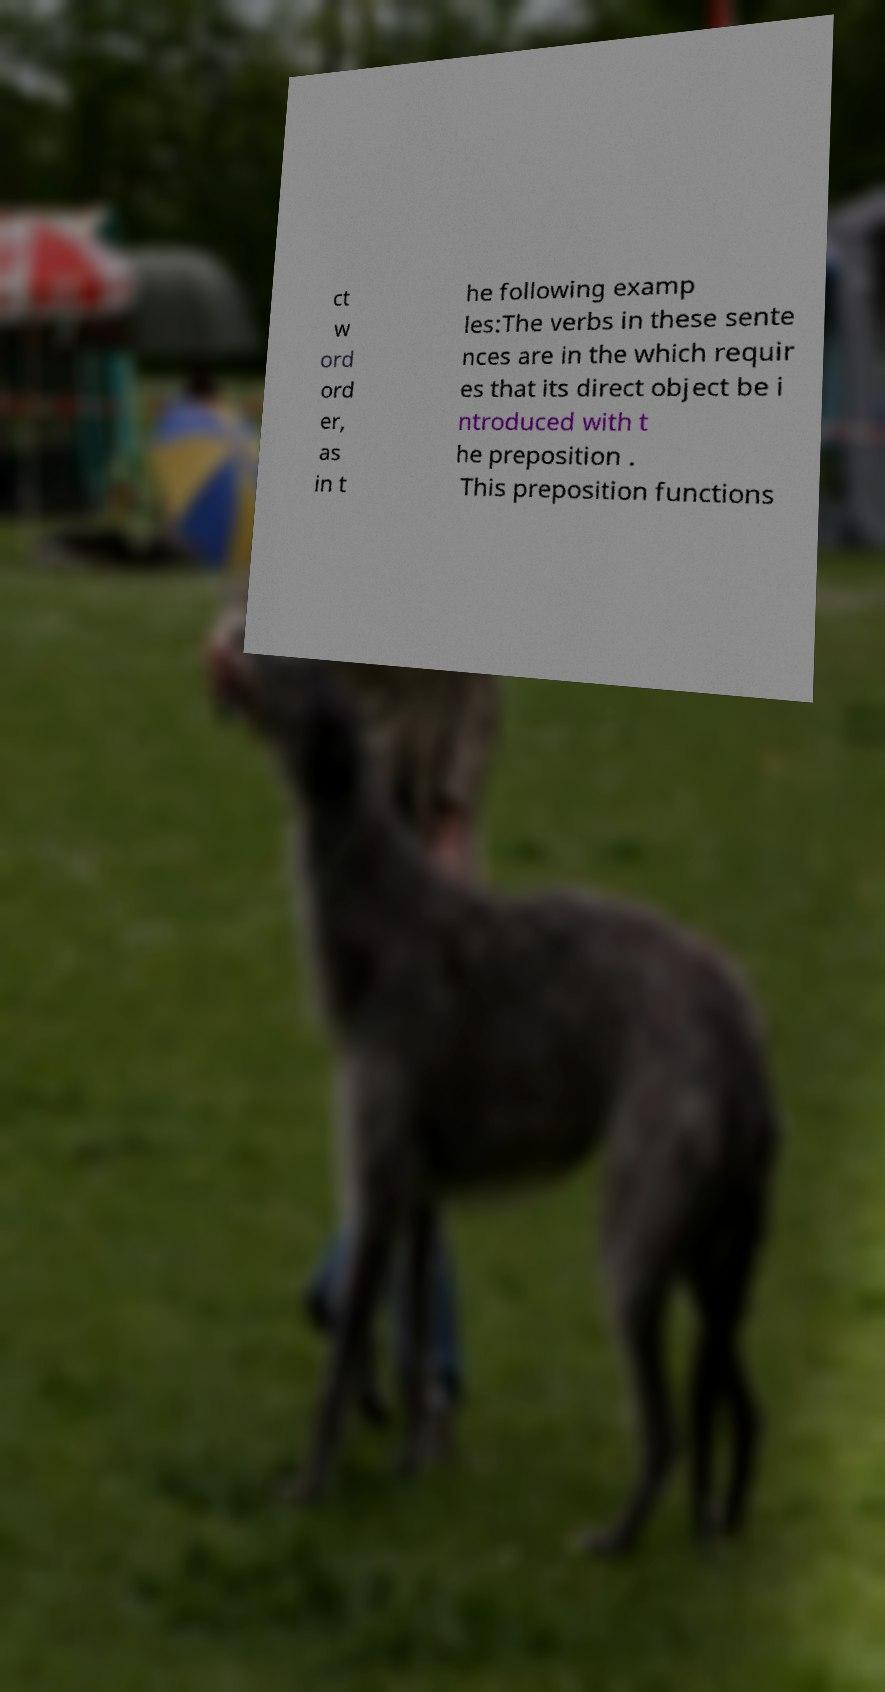What messages or text are displayed in this image? I need them in a readable, typed format. ct w ord ord er, as in t he following examp les:The verbs in these sente nces are in the which requir es that its direct object be i ntroduced with t he preposition . This preposition functions 